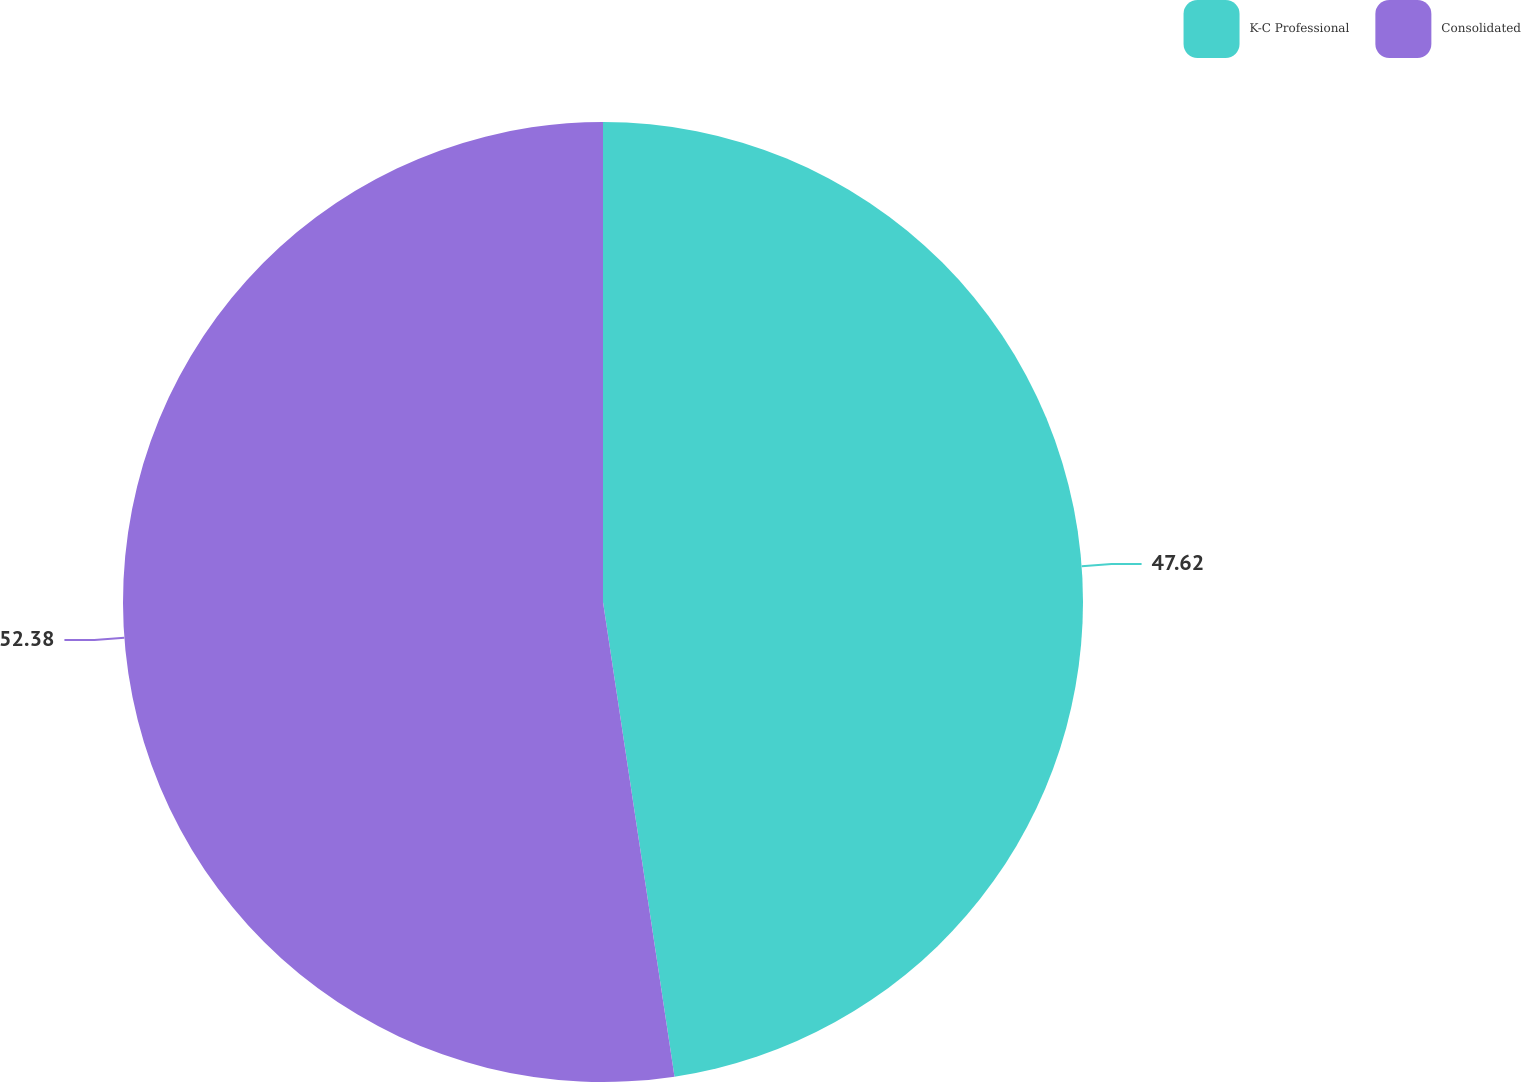Convert chart to OTSL. <chart><loc_0><loc_0><loc_500><loc_500><pie_chart><fcel>K-C Professional<fcel>Consolidated<nl><fcel>47.62%<fcel>52.38%<nl></chart> 